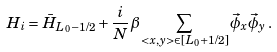<formula> <loc_0><loc_0><loc_500><loc_500>H _ { i } = \bar { H } _ { L _ { 0 } - 1 / 2 } + \frac { i } { N } \beta \sum _ { < x , y > \in [ L _ { 0 } + 1 / 2 ] } \vec { \phi } _ { x } \vec { \phi } _ { y } \, .</formula> 